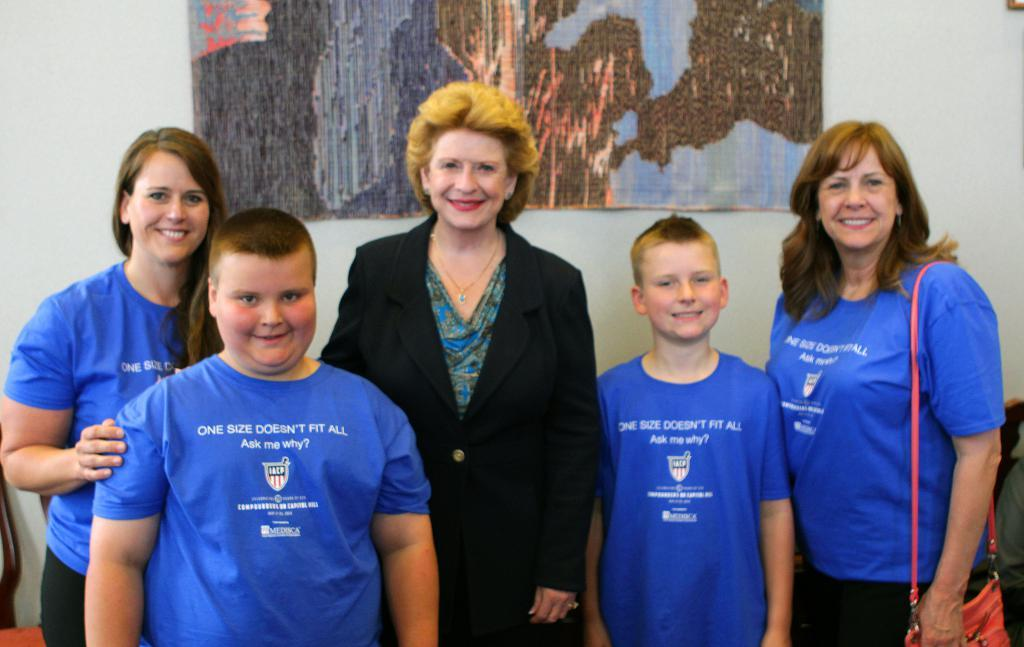Provide a one-sentence caption for the provided image. A group of people, four of which are wearing blue shirts saying "One size doesn't fit all". 